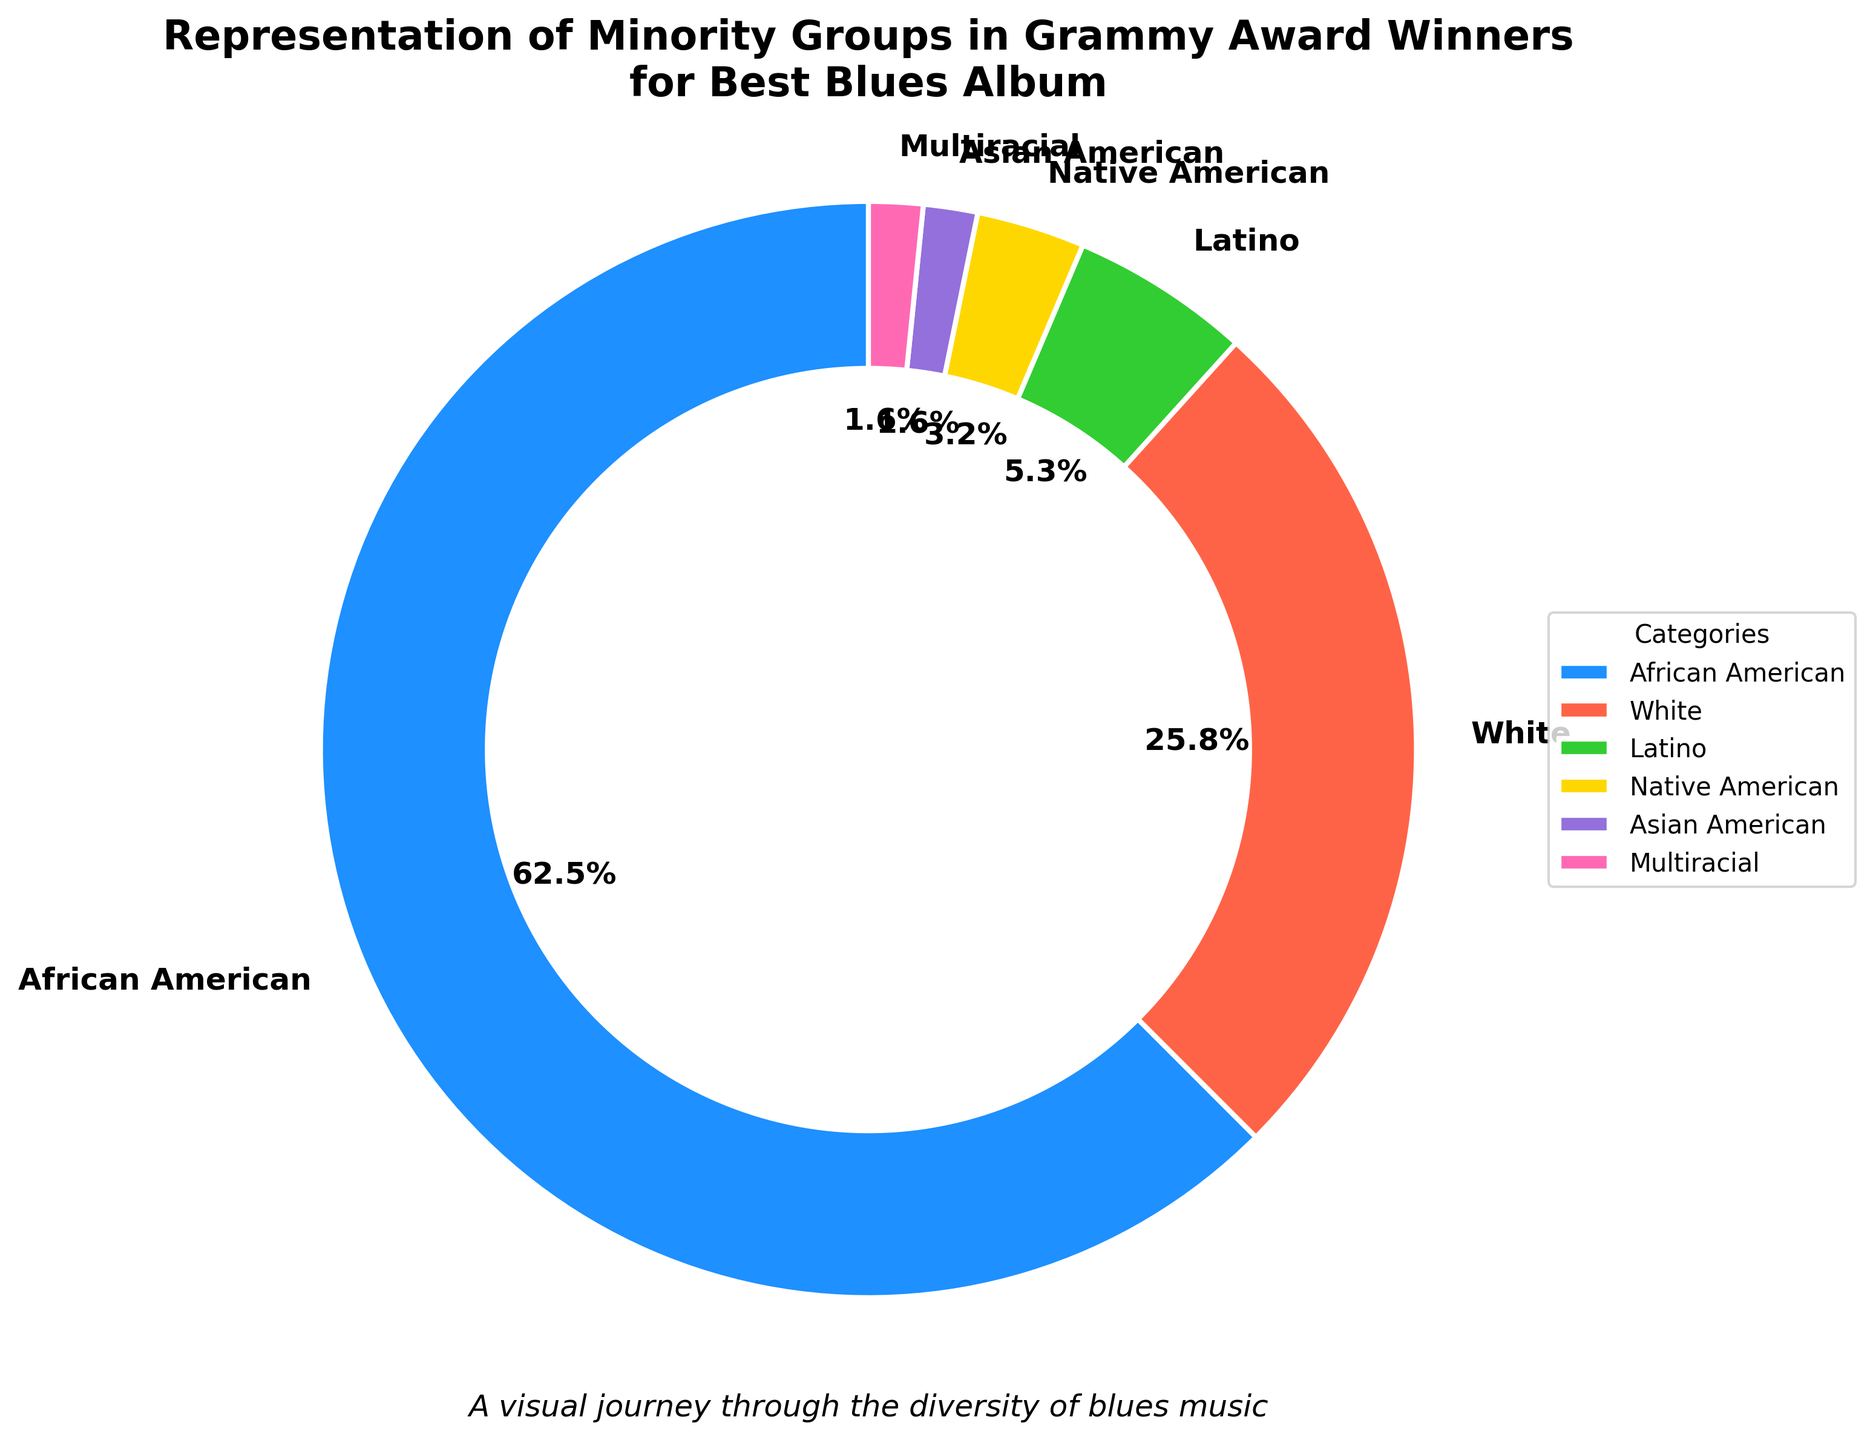What's the percentage representation of African American winners? The chart shows that African American winners constitute a specific portion of the total. By looking at the chart, the percentage label for African American winners is shown.
Answer: 62.5% How does the representation of White winners compare to African American winners? To compare, visually note the percentage of White winners and African American winners from the chart. African American winners have 62.5% and White winners have 25.8%. Since 62.5% is greater than 25.8%, African American winners are more represented.
Answer: African American winners are more represented Which group has the least representation in Grammy Award winners for Best Blues Album? Check the pie chart for the group with the smallest percentage. The chart shows Latino, Native American, and Asian American groups. Among them, Asian American and Multiracial have the smallest, each with 1.6%.
Answer: Asian American and Multiracial What is the total representation percentage of Minority Groups other than African American and White? To get the total percentage, add the percentages of Latino, Native American, Asian American, and Multiracial groups shown in the chart. The values to sum are 5.3%, 3.2%, 1.6%, and 1.6%, respectively. Summing these gives 5.3 + 3.2 + 1.6 + 1.6 = 11.7%.
Answer: 11.7% Which color represents the Native American group in the pie chart? The pie chart uses different colors for different groups. Each section of the pie chart is labeled with the group it represents. The color for Native American winners is the third section.
Answer: yellow What is the difference in representation percentage between African American and Latino winners? Look at the percentages for African American and Latino representations. African American winners have 62.5% and Latino winners have 5.3%. The difference is 62.5% - 5.3%.
Answer: 57.2% What's the combined representation percentage of the top two groups? To find the combined percentage of the top two represented groups, add the percentages of African American and White groups. Their values are 62.5% and 25.8%, respectively. Adding them gives 62.5 + 25.8 = 88.3%.
Answer: 88.3% What is the representation percentage of Multiracial winners, and how does it compare to Asian American winners? Check the chart for the percentages of Multiracial and Asian American groups. Both groups have the same value. The chart labels both groups with 1.6%.
Answer: Both are 1.6% How many groups have a representation of less than 10%? Identify groups from the pie chart with representation below 10%. These groups are Latino, Native American, Asian American, and Multiracial. There are four such groups.
Answer: 4 